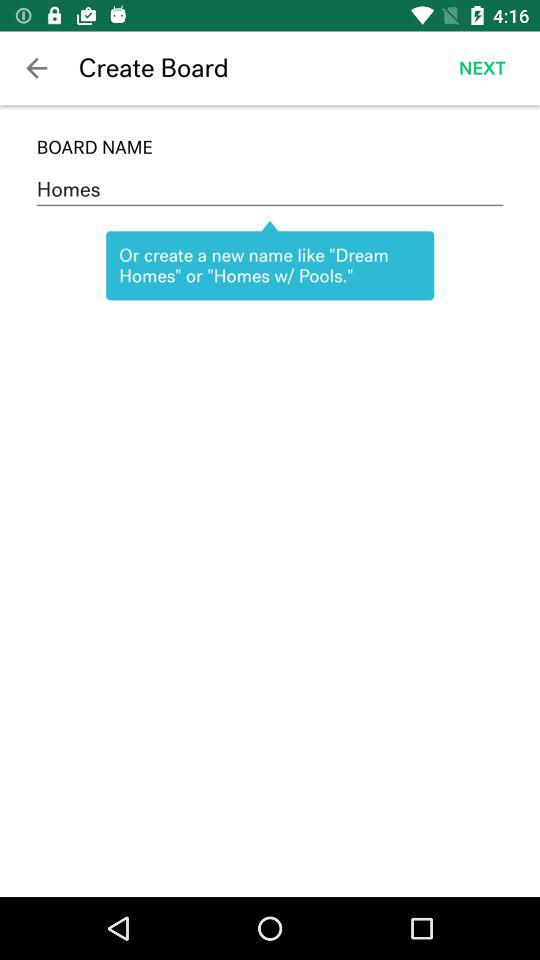How many boards were created?
When the provided information is insufficient, respond with <no answer>. <no answer> 